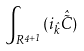Convert formula to latex. <formula><loc_0><loc_0><loc_500><loc_500>\int _ { R ^ { 4 + 1 } } ( i _ { \hat { k } } { \hat { \tilde { C } } } )</formula> 